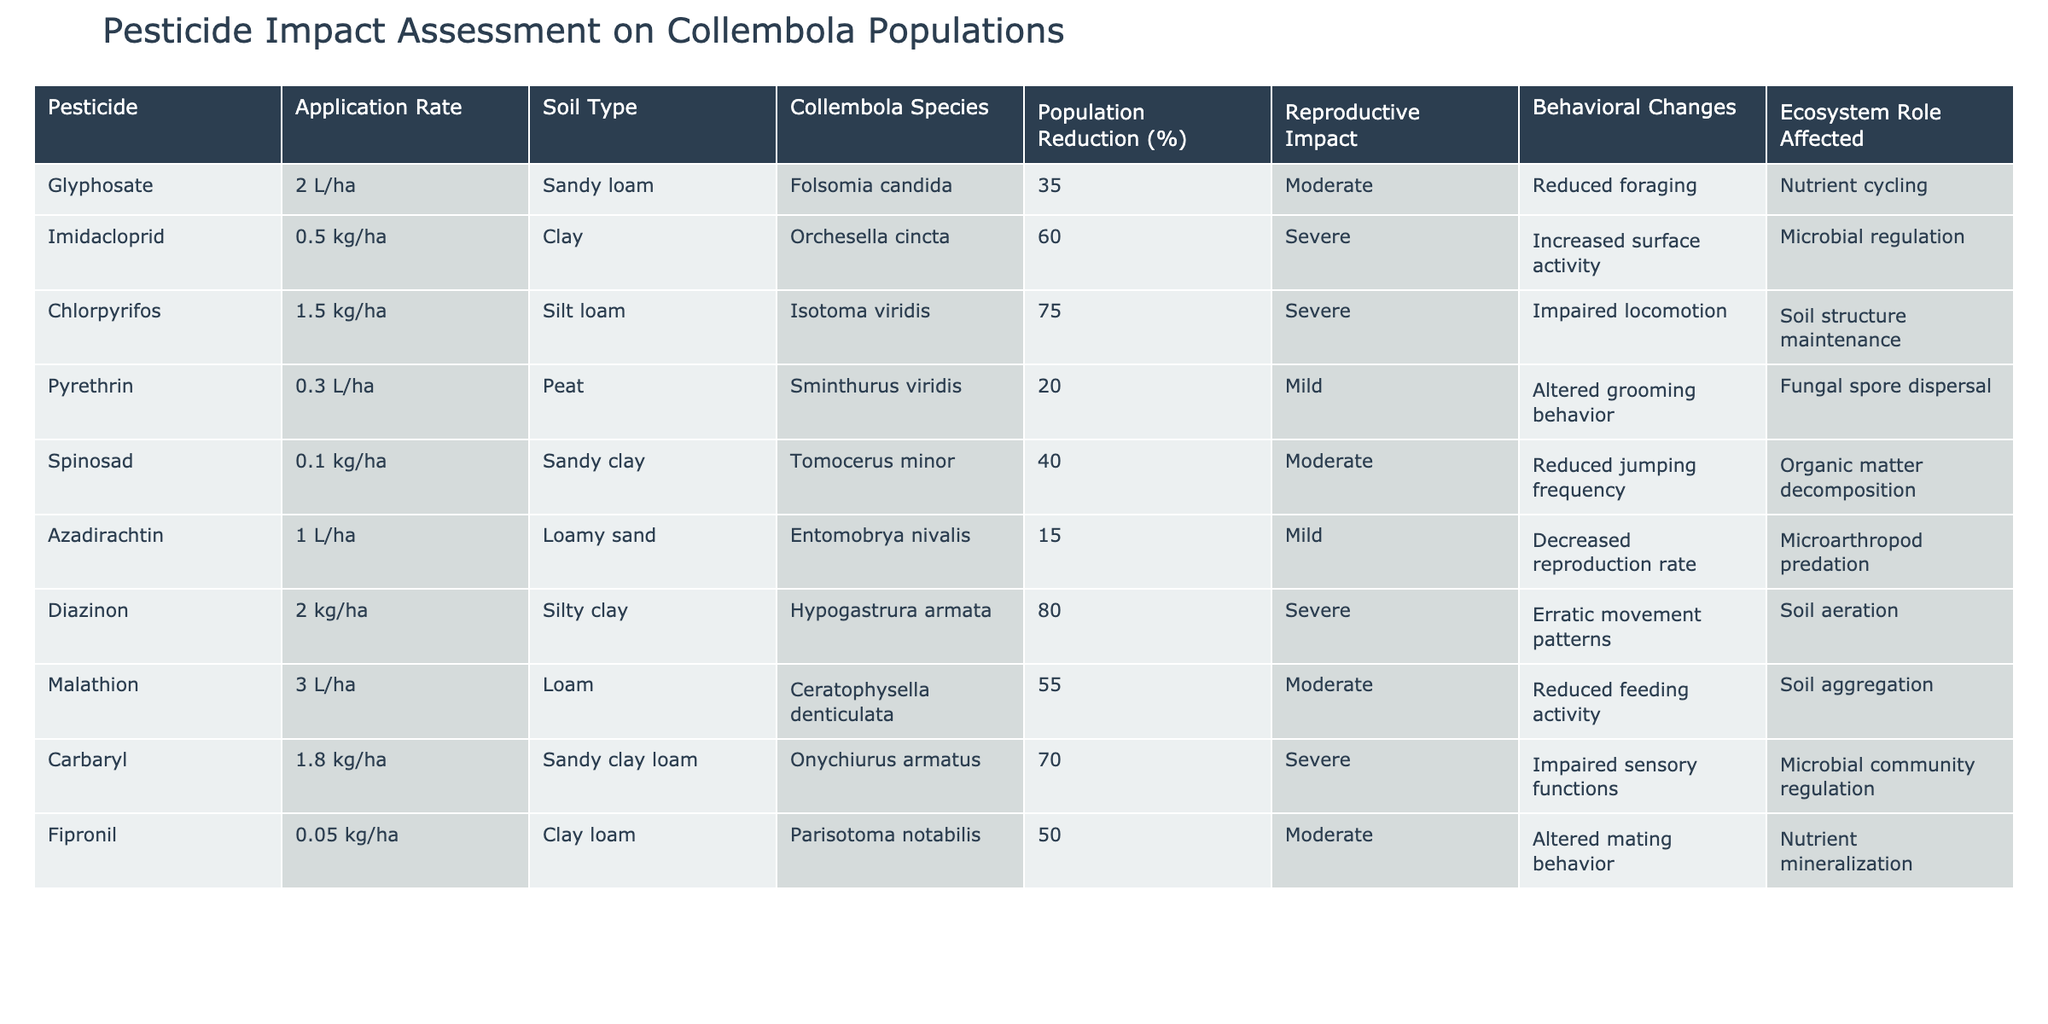What pesticide resulted in the highest population reduction of Collembola? The highest population reduction is found in the row for Diazinon, where the reduction is 80%.
Answer: Diazinon Which Collembola species experienced a moderate reproductive impact? The species that had a moderate reproductive impact as listed in the table are Folsomia candida, Spinosad, Fipronil, and Malathion.
Answer: Folsomia candida, Spinosad, Fipronil, Malathion What is the average population reduction for pesticides with a severe reproductive impact? The pesticides with a severe reproductive impact are Imidacloprid, Chlorpyrifos, Diazinon, and Carbaryl, with population reductions of 60%, 75%, 80%, and 70%, respectively. The average is calculated as (60 + 75 + 80 + 70) / 4 = 71.25%.
Answer: 71.25% Did any pesticide show a mild reproductive impact and also result in altered grooming behavior? Yes, Pyrethrin shows a mild reproductive impact and is associated with altered grooming behavior.
Answer: Yes Which soil type associated with pesticide application has the lowest average population reduction? To find this, we compile the population reduction percentages by soil type: Sandy loam (35% from Glyphosate), Clay (60% from Imidacloprid), Silt loam (75% from Chlorpyrifos), Peat (20% from Pyrethrin), Sandy clay (40% from Spinosad), Loamy sand (15% from Azadirachtin), Silty clay (80% from Diazinon), Loam (55% from Malathion), Sandy clay loam (70% from Carbaryl), and Clay loam (50% from Fipronil). The average for Peat is 20%, which is the lowest.
Answer: Peat 